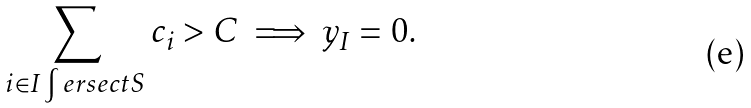<formula> <loc_0><loc_0><loc_500><loc_500>\sum _ { i \in I \int e r s e c t S } c _ { i } > C \implies y _ { I } = 0 .</formula> 